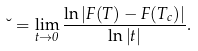Convert formula to latex. <formula><loc_0><loc_0><loc_500><loc_500>\lambda = \lim _ { t \rightarrow 0 } \frac { \ln | F ( T ) - F ( T _ { c } ) | } { \ln | t | } .</formula> 